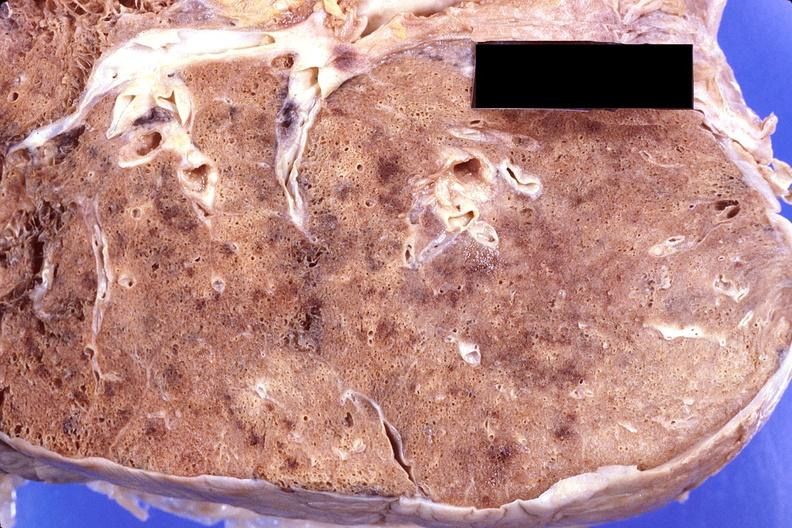what does this image show?
Answer the question using a single word or phrase. Lung 